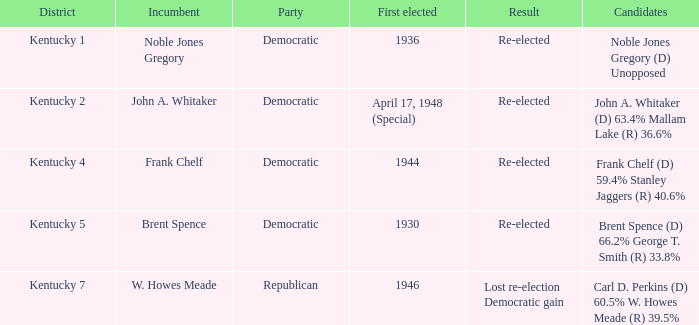Which political group emerged victorious in kentucky's 5th voting district election? Democratic. 